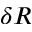Convert formula to latex. <formula><loc_0><loc_0><loc_500><loc_500>\delta R</formula> 